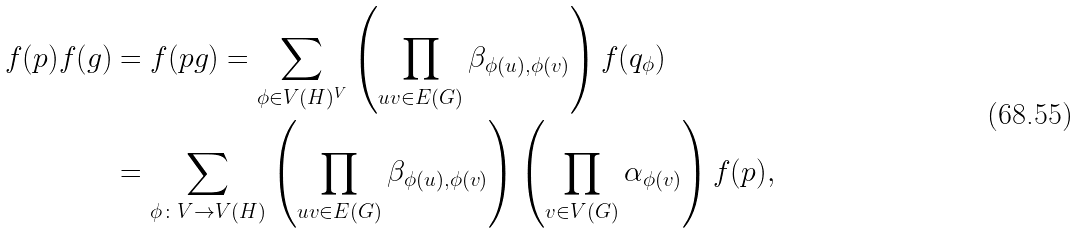<formula> <loc_0><loc_0><loc_500><loc_500>f ( p ) f ( g ) & = f ( p g ) = \sum _ { \phi \in V ( H ) ^ { V } } \left ( \prod _ { u v \in E ( G ) } \beta _ { \phi ( u ) , \phi ( v ) } \right ) f ( q _ { \phi } ) \\ & = \sum _ { \phi \colon V \to V ( H ) } \left ( \prod _ { u v \in E ( G ) } \beta _ { \phi ( u ) , \phi ( v ) } \right ) \left ( \prod _ { v \in V ( G ) } \alpha _ { \phi ( v ) } \right ) f ( p ) ,</formula> 